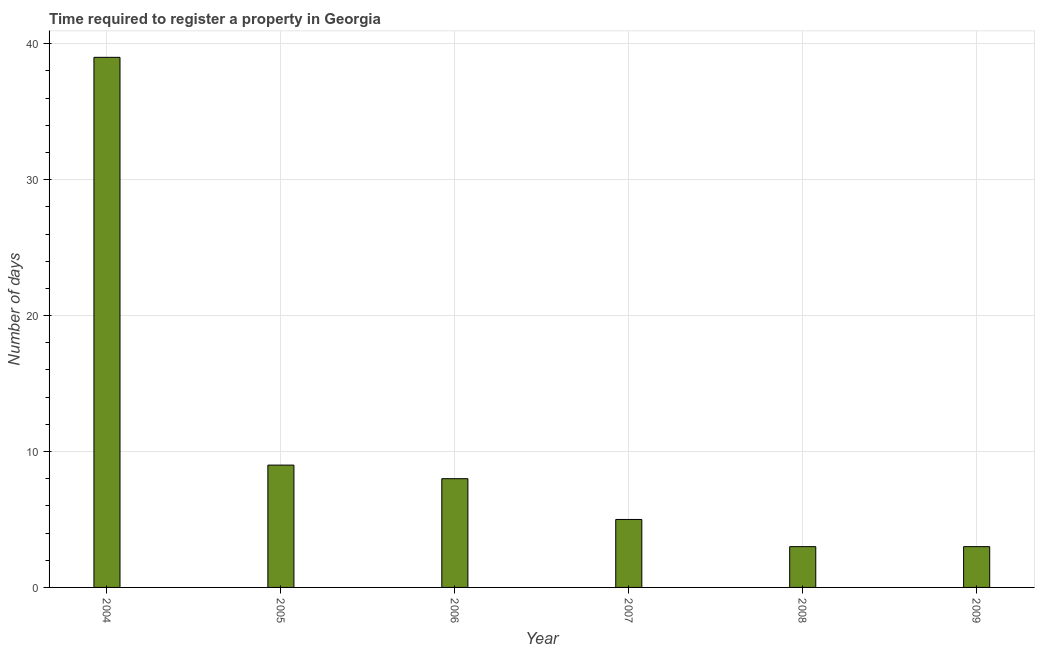Does the graph contain grids?
Your answer should be very brief. Yes. What is the title of the graph?
Your answer should be compact. Time required to register a property in Georgia. What is the label or title of the Y-axis?
Give a very brief answer. Number of days. What is the number of days required to register property in 2004?
Make the answer very short. 39. In which year was the number of days required to register property maximum?
Your answer should be compact. 2004. In which year was the number of days required to register property minimum?
Ensure brevity in your answer.  2008. What is the sum of the number of days required to register property?
Ensure brevity in your answer.  67. Do a majority of the years between 2008 and 2006 (inclusive) have number of days required to register property greater than 34 days?
Your answer should be very brief. Yes. What is the ratio of the number of days required to register property in 2007 to that in 2009?
Provide a succinct answer. 1.67. Is the number of days required to register property in 2004 less than that in 2008?
Offer a terse response. No. Is the difference between the number of days required to register property in 2004 and 2008 greater than the difference between any two years?
Give a very brief answer. Yes. What is the difference between the highest and the second highest number of days required to register property?
Offer a very short reply. 30. What is the difference between the highest and the lowest number of days required to register property?
Ensure brevity in your answer.  36. In how many years, is the number of days required to register property greater than the average number of days required to register property taken over all years?
Your answer should be very brief. 1. Are all the bars in the graph horizontal?
Give a very brief answer. No. What is the Number of days of 2004?
Keep it short and to the point. 39. What is the Number of days in 2005?
Provide a succinct answer. 9. What is the Number of days in 2006?
Offer a very short reply. 8. What is the Number of days of 2007?
Make the answer very short. 5. What is the difference between the Number of days in 2004 and 2005?
Offer a very short reply. 30. What is the difference between the Number of days in 2004 and 2006?
Keep it short and to the point. 31. What is the difference between the Number of days in 2004 and 2009?
Provide a succinct answer. 36. What is the difference between the Number of days in 2005 and 2007?
Make the answer very short. 4. What is the difference between the Number of days in 2007 and 2009?
Offer a very short reply. 2. What is the difference between the Number of days in 2008 and 2009?
Provide a short and direct response. 0. What is the ratio of the Number of days in 2004 to that in 2005?
Provide a short and direct response. 4.33. What is the ratio of the Number of days in 2004 to that in 2006?
Offer a very short reply. 4.88. What is the ratio of the Number of days in 2004 to that in 2007?
Ensure brevity in your answer.  7.8. What is the ratio of the Number of days in 2004 to that in 2008?
Provide a short and direct response. 13. What is the ratio of the Number of days in 2004 to that in 2009?
Provide a short and direct response. 13. What is the ratio of the Number of days in 2006 to that in 2008?
Give a very brief answer. 2.67. What is the ratio of the Number of days in 2006 to that in 2009?
Make the answer very short. 2.67. What is the ratio of the Number of days in 2007 to that in 2008?
Your answer should be very brief. 1.67. What is the ratio of the Number of days in 2007 to that in 2009?
Your response must be concise. 1.67. 